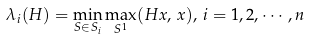Convert formula to latex. <formula><loc_0><loc_0><loc_500><loc_500>\lambda _ { i } ( H ) = \min _ { S \in S _ { i } } \max _ { S ^ { 1 } } ( H x , \, x ) , \, i = 1 , 2 , \cdots , n</formula> 